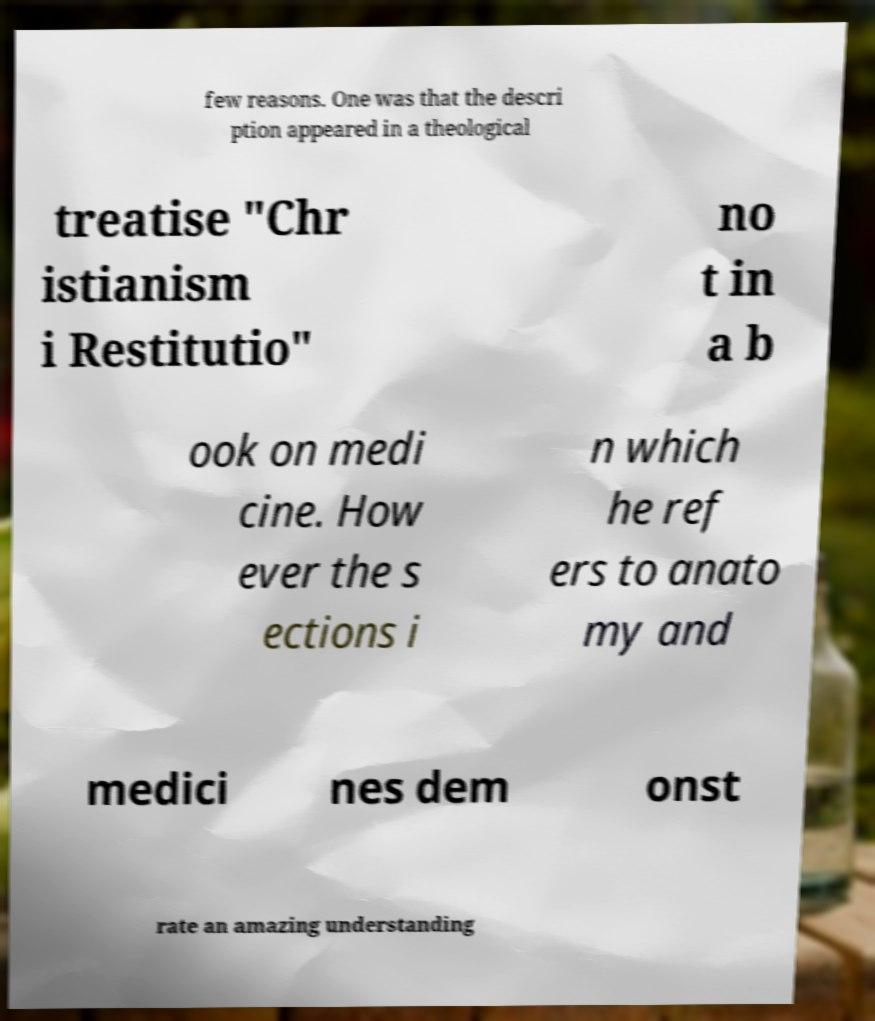I need the written content from this picture converted into text. Can you do that? few reasons. One was that the descri ption appeared in a theological treatise "Chr istianism i Restitutio" no t in a b ook on medi cine. How ever the s ections i n which he ref ers to anato my and medici nes dem onst rate an amazing understanding 